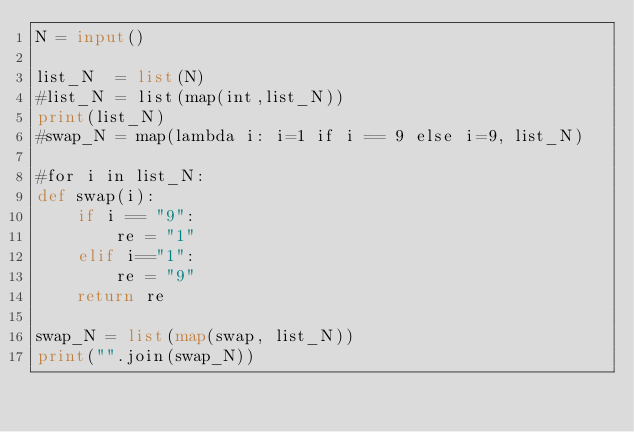Convert code to text. <code><loc_0><loc_0><loc_500><loc_500><_Python_>N = input()

list_N  = list(N) 
#list_N = list(map(int,list_N))
print(list_N)
#swap_N = map(lambda i: i=1 if i == 9 else i=9, list_N)

#for i in list_N:
def swap(i):
    if i == "9":
        re = "1"
    elif i=="1":
        re = "9"
    return re

swap_N = list(map(swap, list_N))
print("".join(swap_N))</code> 